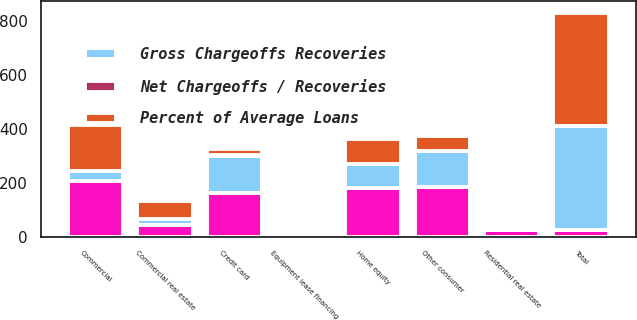Convert chart. <chart><loc_0><loc_0><loc_500><loc_500><stacked_bar_chart><ecel><fcel>Commercial<fcel>Commercial real estate<fcel>Equipment lease financing<fcel>Home equity<fcel>Residential real estate<fcel>Credit card<fcel>Other consumer<fcel>Total<nl><fcel>nan<fcel>206<fcel>44<fcel>5<fcel>181<fcel>24<fcel>160<fcel>185<fcel>24<nl><fcel>Percent of Average Loans<fcel>170<fcel>66<fcel>4<fcel>93<fcel>13<fcel>21<fcel>52<fcel>419<nl><fcel>Gross Chargeoffs Recoveries<fcel>36<fcel>22<fcel>1<fcel>88<fcel>11<fcel>139<fcel>133<fcel>386<nl><fcel>Net Chargeoffs / Recoveries<fcel>0.04<fcel>0.09<fcel>0.01<fcel>0.26<fcel>0.08<fcel>3.06<fcel>0.6<fcel>0.19<nl></chart> 